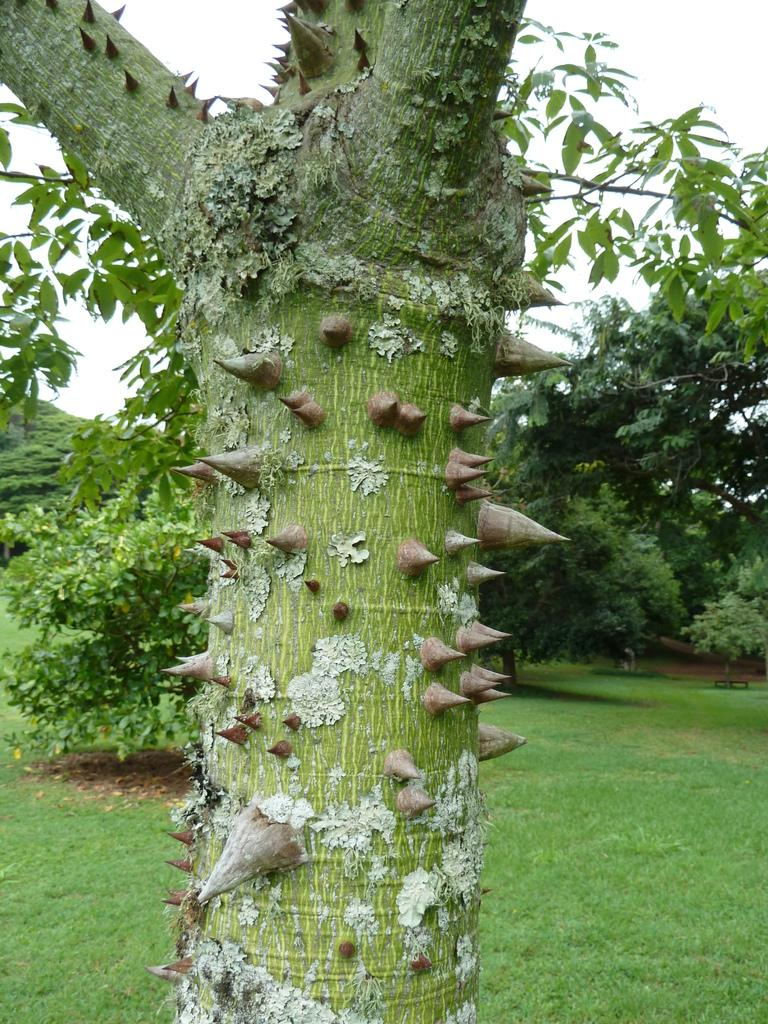What is the main subject of the image? The main subject of the image is a tree trunk with thorns. What can be seen in the background of the image? There are trees and grass in the background of the image. What is visible in the sky in the image? The sky is visible in the background of the image. How many ears can be seen on the tree trunk in the image? There are no ears present on the tree trunk or in the image; it is a tree trunk with thorns. 